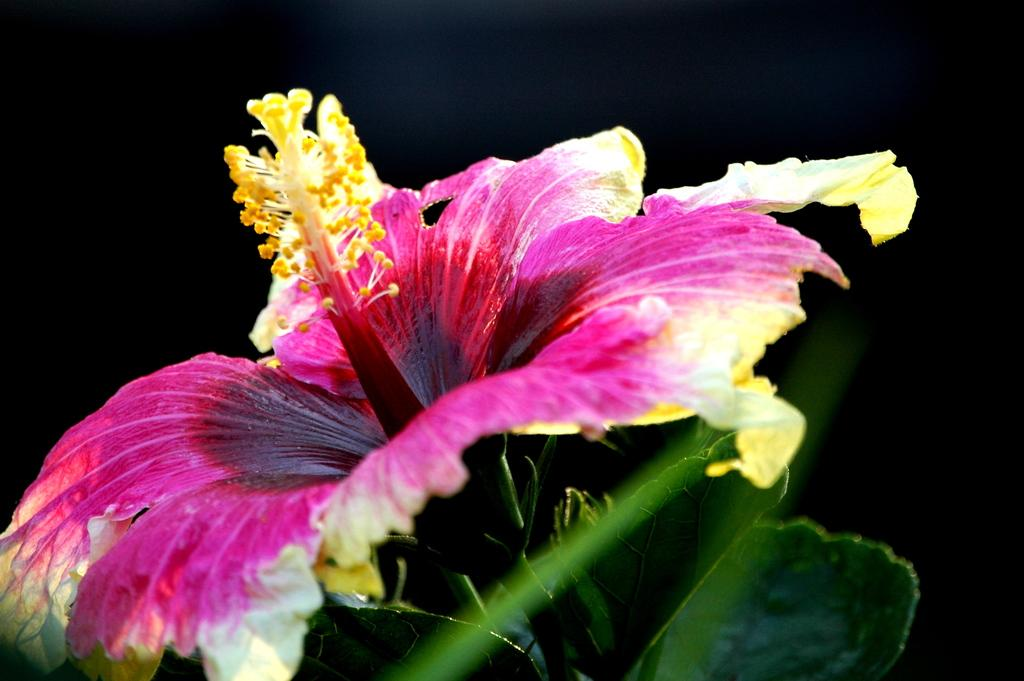What is the color of the background in the image? The background of the image is dark. What type of flower can be seen in the image? There is a datura flower in the image. What other plant elements are visible in the image? Green leaves are visible in the image. How many competitors are participating in the nose-picking competition in the image? There is no nose-picking competition present in the image. What is the range of the datura flower in the image? The range of the datura flower cannot be determined from the image, as it is a static photograph. 